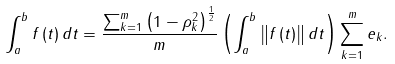Convert formula to latex. <formula><loc_0><loc_0><loc_500><loc_500>\int _ { a } ^ { b } f \left ( t \right ) d t = \frac { \sum _ { k = 1 } ^ { m } \left ( 1 - \rho _ { k } ^ { 2 } \right ) ^ { \frac { 1 } { 2 } } } { m } \left ( \int _ { a } ^ { b } \left \| f \left ( t \right ) \right \| d t \right ) \sum _ { k = 1 } ^ { m } e _ { k } .</formula> 